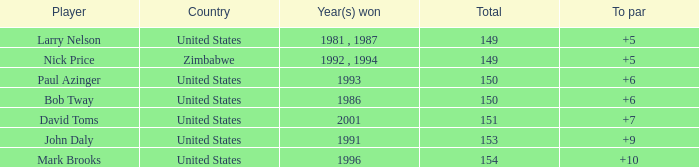What is zimbabwe's total with a to par exceeding 5? None. 